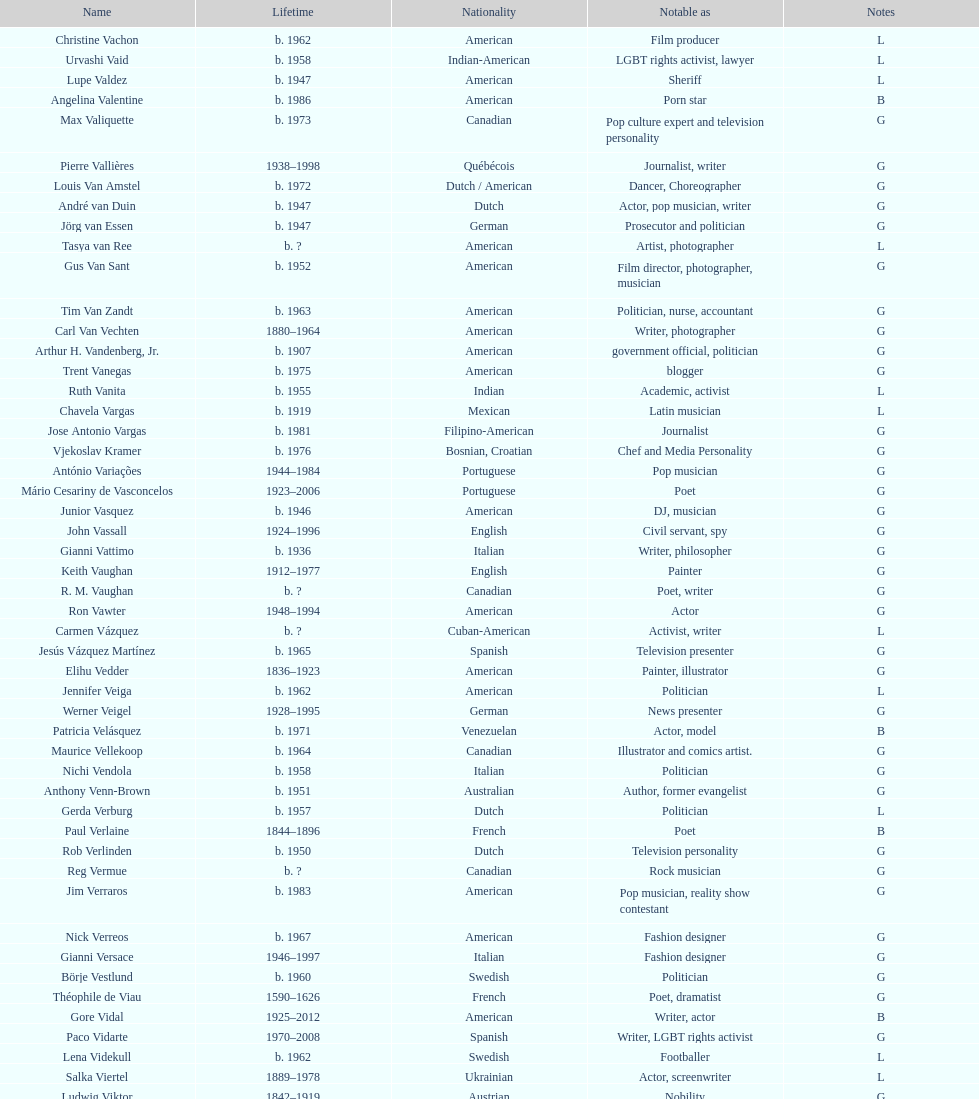What is the difference in birth year between vachon and vaid? 4 years. 